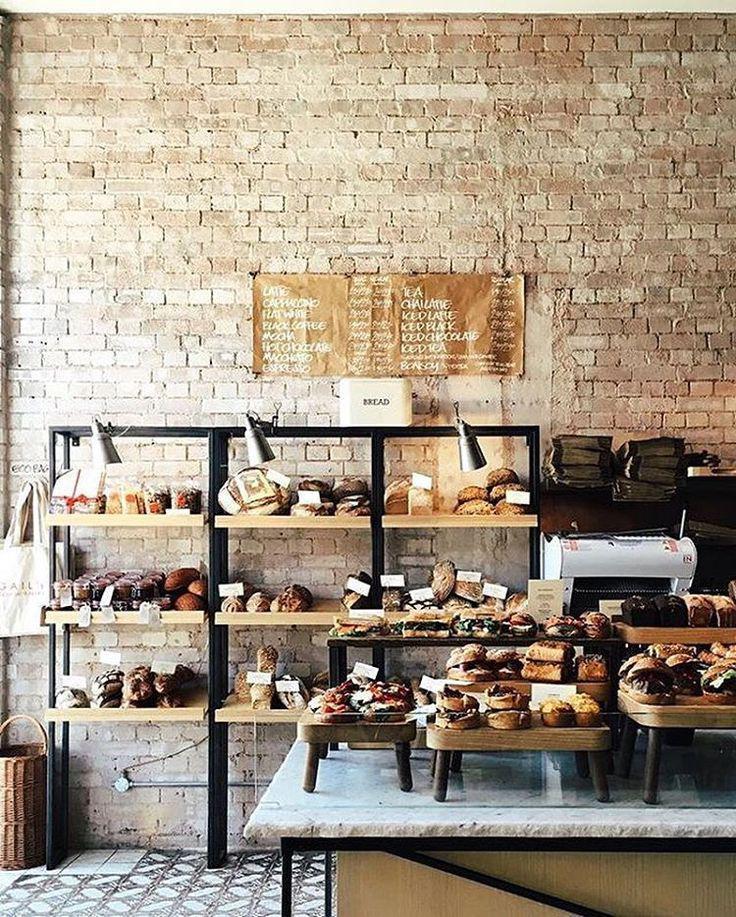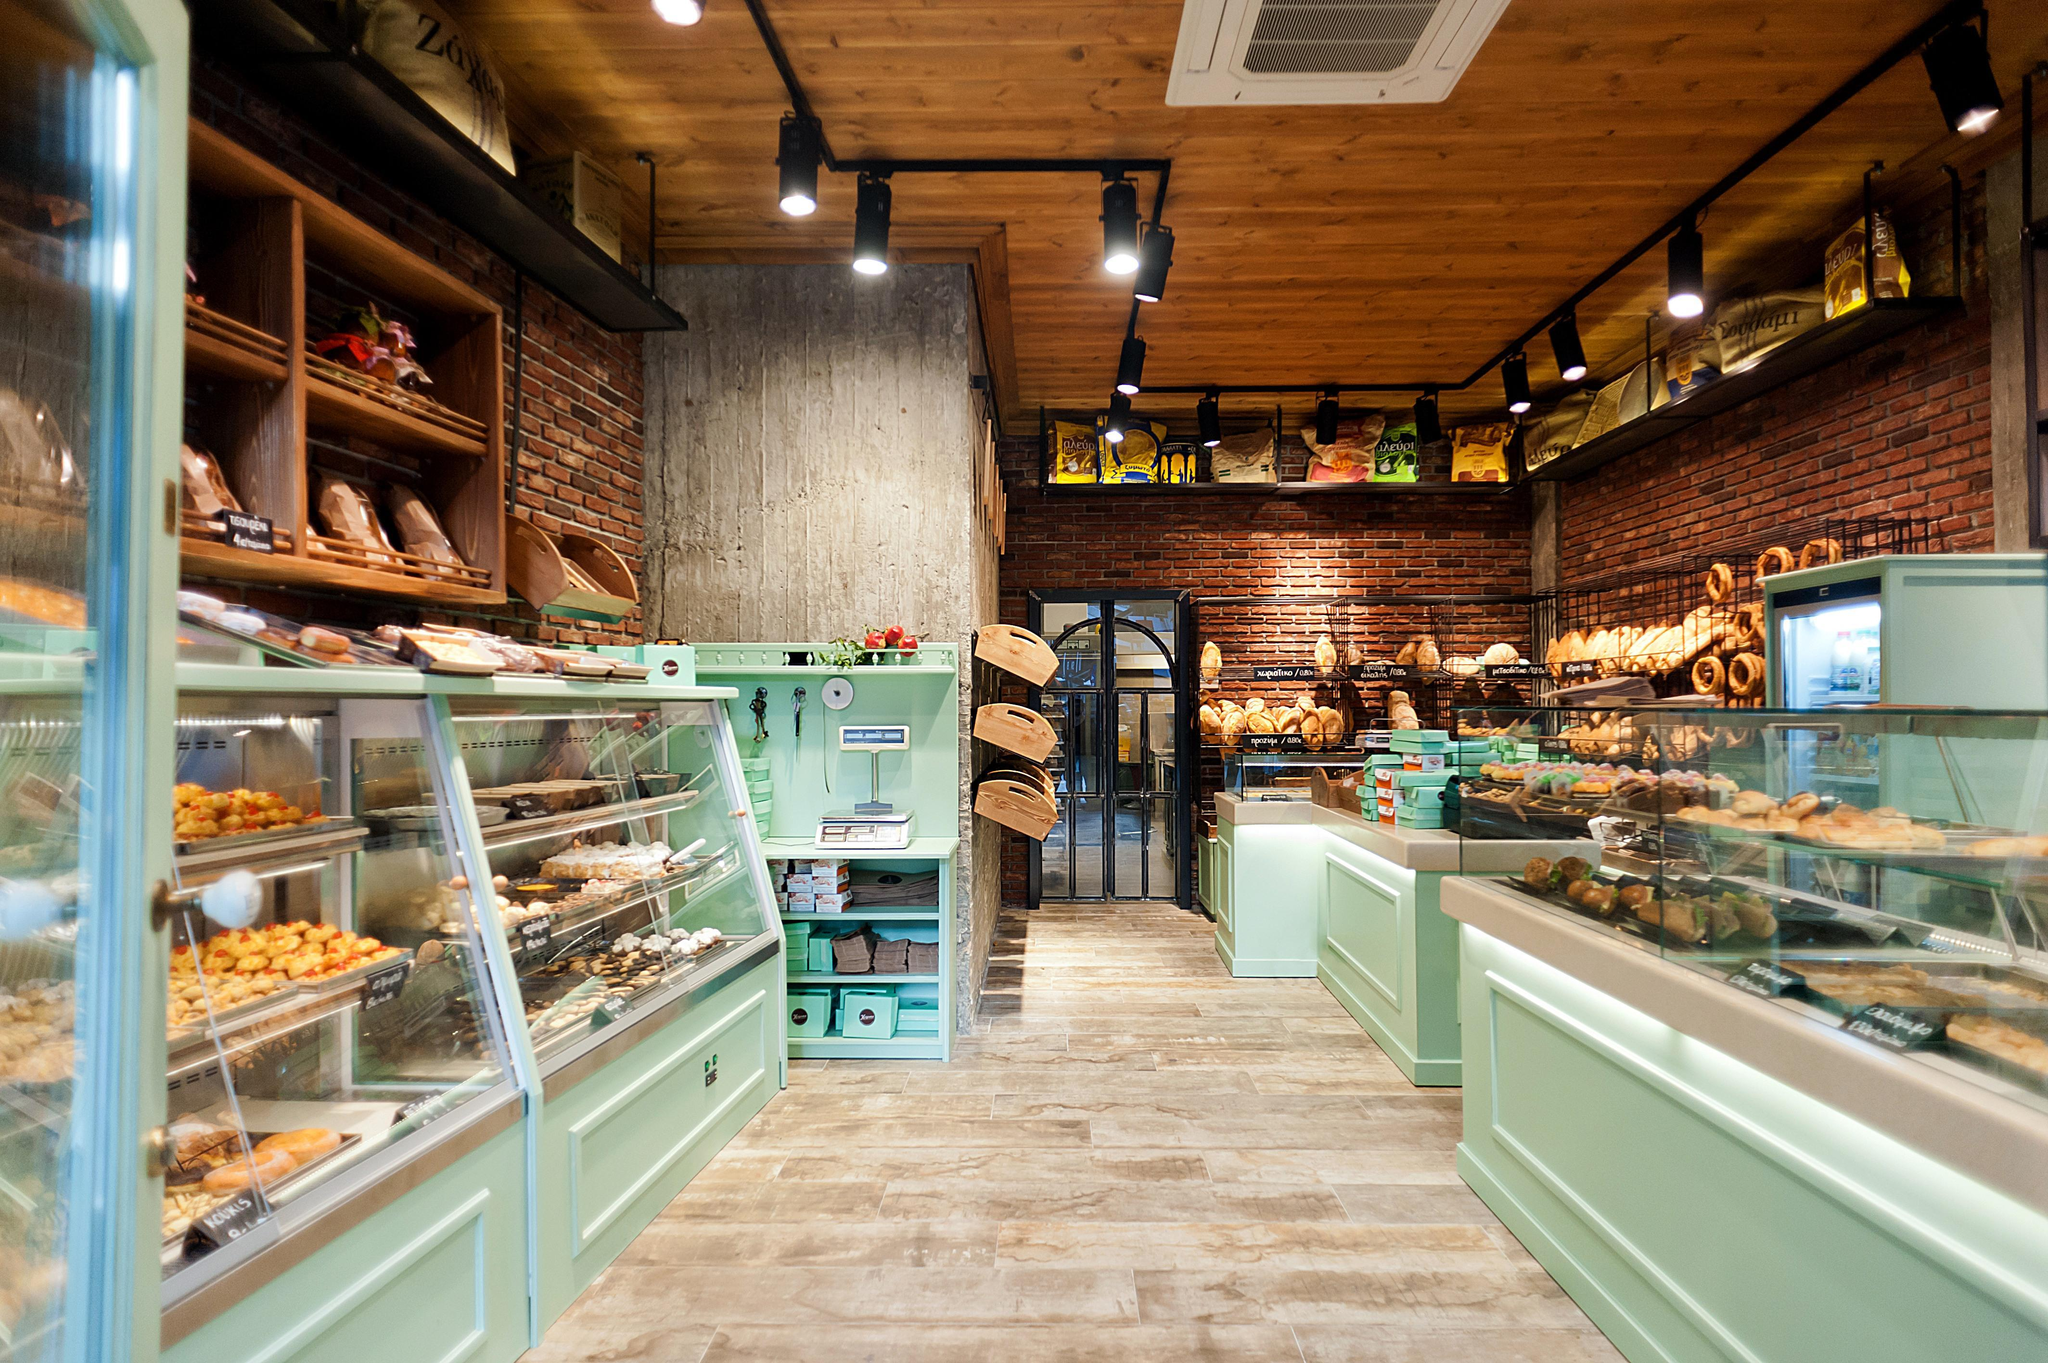The first image is the image on the left, the second image is the image on the right. For the images shown, is this caption "Right image shows a bakery with pale green display cases and black track lighting suspended from a wood plank ceiling." true? Answer yes or no. Yes. The first image is the image on the left, the second image is the image on the right. For the images displayed, is the sentence "There is at least one square table with chairs inside a bakery." factually correct? Answer yes or no. No. 